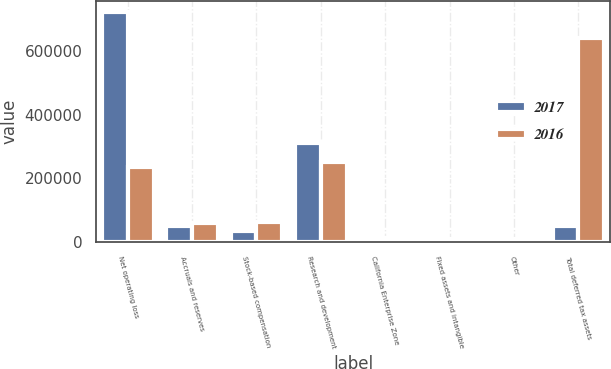Convert chart to OTSL. <chart><loc_0><loc_0><loc_500><loc_500><stacked_bar_chart><ecel><fcel>Net operating loss<fcel>Accruals and reserves<fcel>Stock-based compensation<fcel>Research and development<fcel>California Enterprise Zone<fcel>Fixed assets and intangible<fcel>Other<fcel>Total deferred tax assets<nl><fcel>2017<fcel>720444<fcel>51948<fcel>36280<fcel>312637<fcel>15119<fcel>10803<fcel>8843<fcel>51948<nl><fcel>2016<fcel>235668<fcel>61594<fcel>64136<fcel>251808<fcel>12266<fcel>2631<fcel>11980<fcel>640083<nl></chart> 